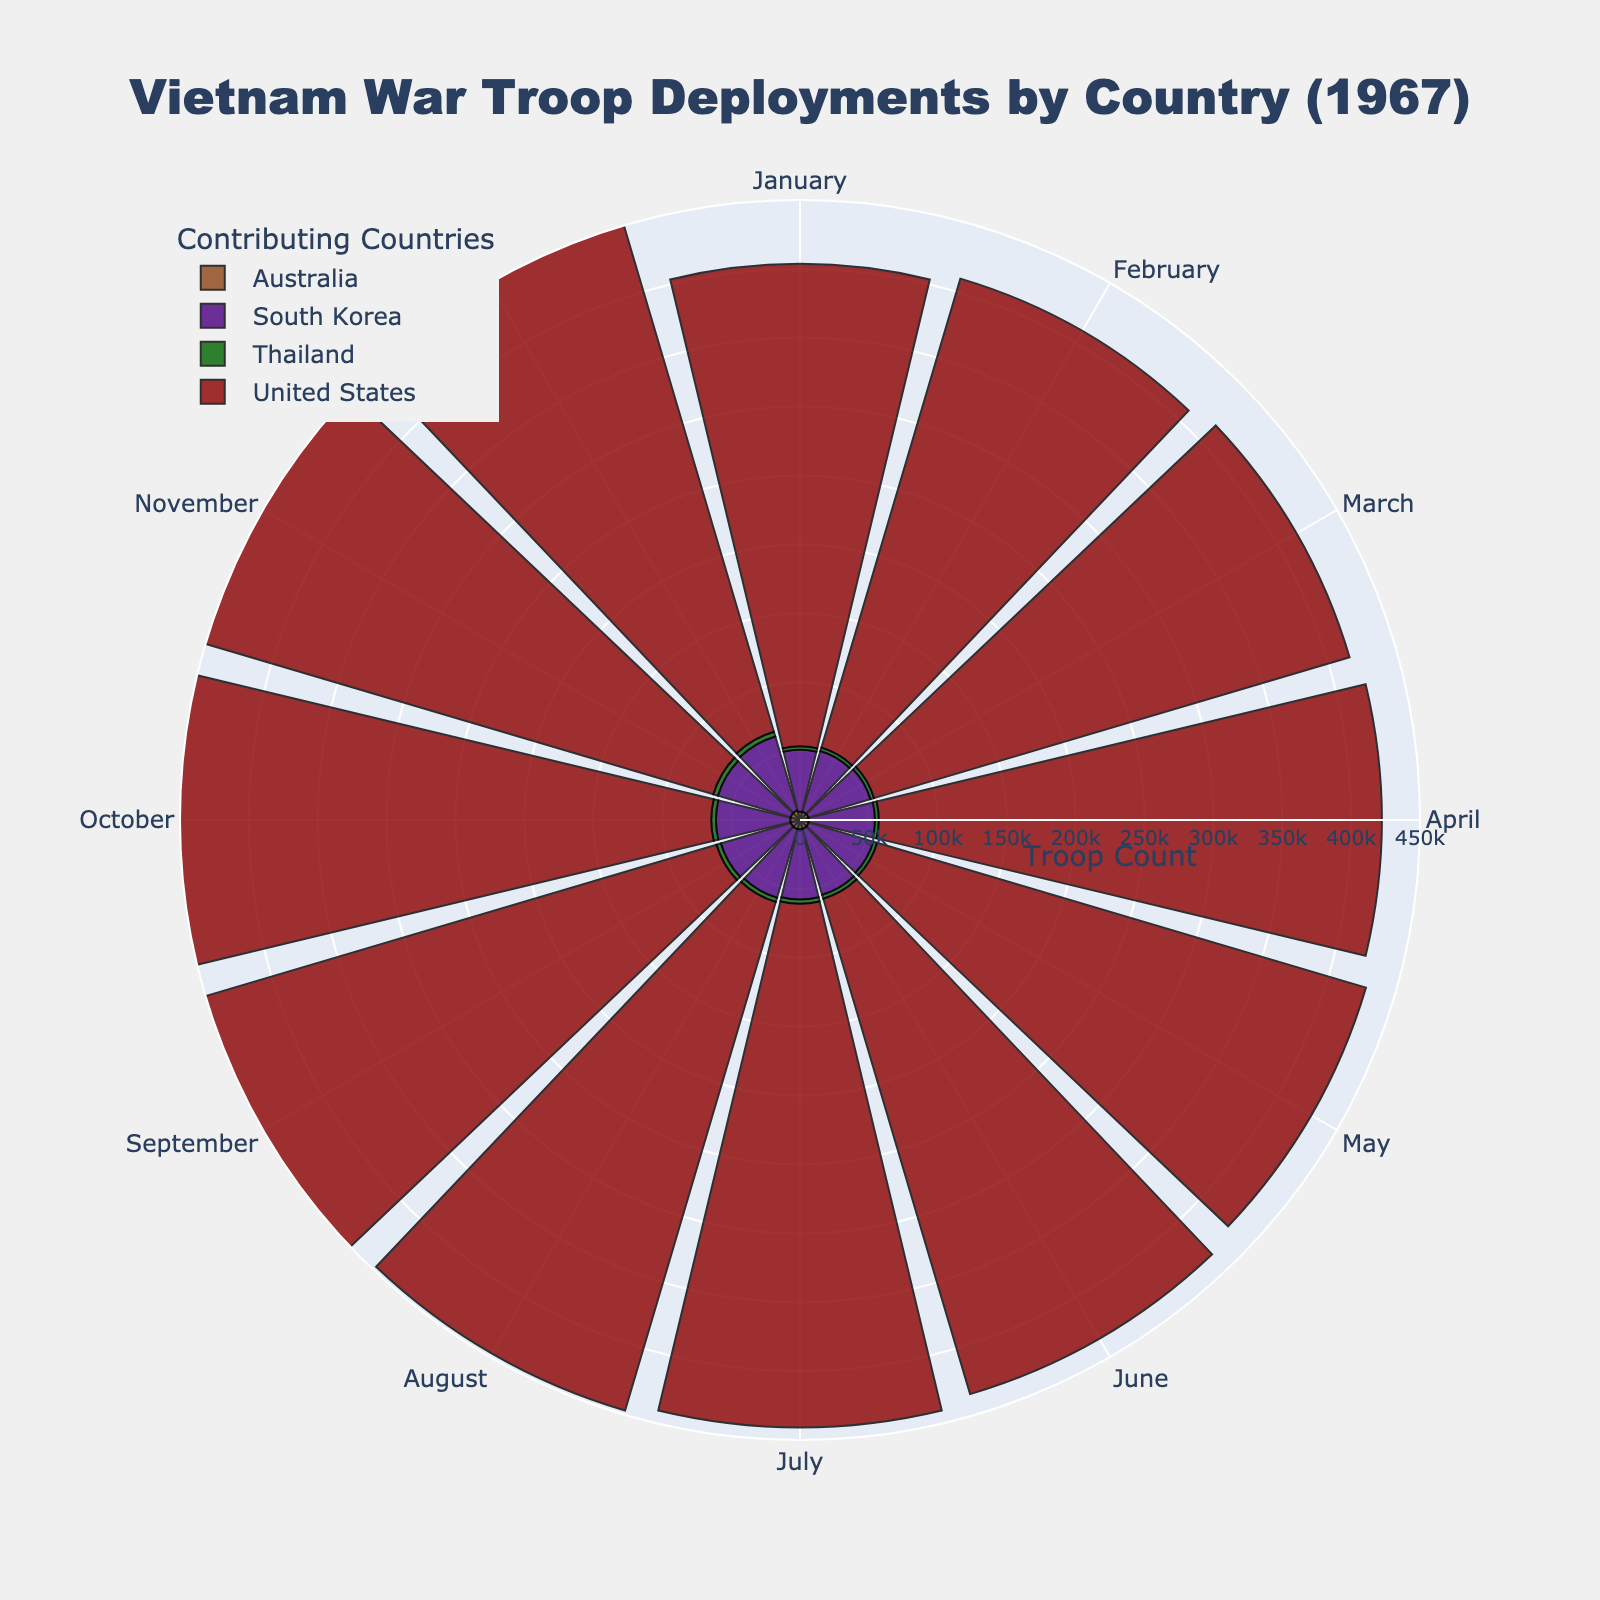What's the title of the figure? The title is located at the top of the figure and typically provides a summary of what the chart is about. Here, it states "Vietnam War Troop Deployments by Country (1967)."
Answer: Vietnam War Troop Deployments by Country (1967) Which country had the highest troop deployment in December 1967? By examining the lengths of the bars in December for each country, the bar for the United States is the longest, indicating the highest troop deployment.
Answer: United States What color represents South Korea in the chart? The chart employs different colors for each country. South Korea is represented using the second color in the sequence, which is purple.
Answer: Purple What is the difference between the troop deployments of the United States and South Korea in January 1967? In January 1967, the United States deployed 350,000 troops and South Korea deployed 45,000 troops. The difference can be calculated as 350,000 - 45,000.
Answer: 305,000 Which month saw the highest troop deployment from Australia, and what was the count? We need to find the month where Australia's bar extends the furthest. This happens in December 1967 with 7,200 troops.
Answer: December 1967, 7,200 How did the troop deployment for Thailand change from January to December 1967? Observing the height of Thailand's bars from January to December, we see a consistent monthly increase. It started at 2,500 and increased to 3,600 by December.
Answer: Increased by 1,100 What can you infer about the trend of troop deployments for the United States throughout 1967? By observing the United States' bar lengths, we see a consistent increase every month from January (350,000) to December (405,000).
Answer: Steadily increasing Compare troop deployments between South Korea and Australia in June 1967. Which country had more troops, and by how many? South Korea had 50,000 troops while Australia had 6,600 troops in June. The difference is 50,000 - 6,600.
Answer: South Korea had 43,400 more troops Calculate the average deployment of troops by Thailand over the year 1967. Summing up Thailand's troop deployments and dividing by 12 (months): (2500 + 2600 + 2700 + 2800 + 2900 + 3000 + 3100 + 3200 + 3300 + 3400 + 3500 + 3600) / 12 = 3,050.
Answer: 3,050 